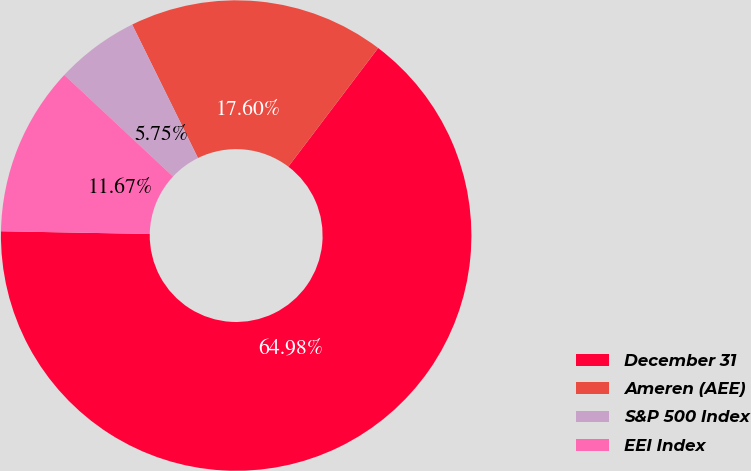Convert chart to OTSL. <chart><loc_0><loc_0><loc_500><loc_500><pie_chart><fcel>December 31<fcel>Ameren (AEE)<fcel>S&P 500 Index<fcel>EEI Index<nl><fcel>64.98%<fcel>17.6%<fcel>5.75%<fcel>11.67%<nl></chart> 